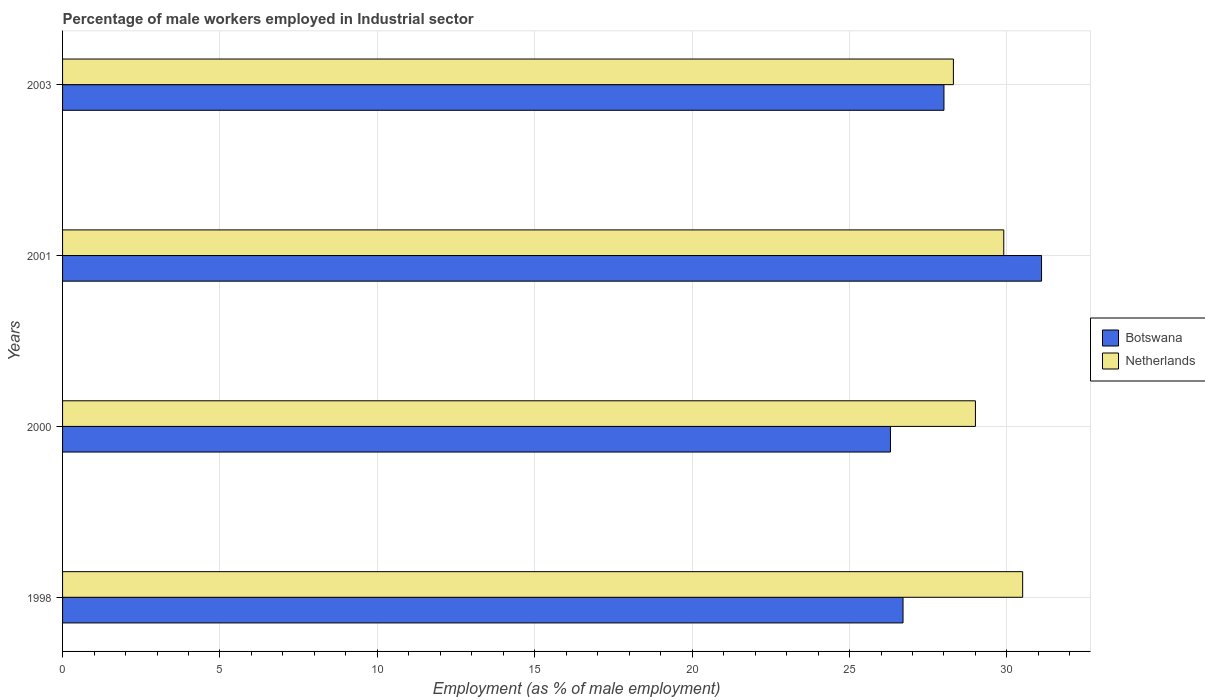Are the number of bars per tick equal to the number of legend labels?
Your response must be concise. Yes. Are the number of bars on each tick of the Y-axis equal?
Make the answer very short. Yes. What is the label of the 2nd group of bars from the top?
Ensure brevity in your answer.  2001. In how many cases, is the number of bars for a given year not equal to the number of legend labels?
Make the answer very short. 0. What is the percentage of male workers employed in Industrial sector in Netherlands in 2001?
Provide a short and direct response. 29.9. Across all years, what is the maximum percentage of male workers employed in Industrial sector in Netherlands?
Provide a succinct answer. 30.5. Across all years, what is the minimum percentage of male workers employed in Industrial sector in Netherlands?
Make the answer very short. 28.3. In which year was the percentage of male workers employed in Industrial sector in Netherlands minimum?
Your answer should be compact. 2003. What is the total percentage of male workers employed in Industrial sector in Botswana in the graph?
Offer a terse response. 112.1. What is the difference between the percentage of male workers employed in Industrial sector in Botswana in 1998 and that in 2003?
Your answer should be compact. -1.3. What is the difference between the percentage of male workers employed in Industrial sector in Botswana in 2001 and the percentage of male workers employed in Industrial sector in Netherlands in 2003?
Make the answer very short. 2.8. What is the average percentage of male workers employed in Industrial sector in Botswana per year?
Give a very brief answer. 28.03. In the year 2001, what is the difference between the percentage of male workers employed in Industrial sector in Botswana and percentage of male workers employed in Industrial sector in Netherlands?
Offer a terse response. 1.2. What is the ratio of the percentage of male workers employed in Industrial sector in Netherlands in 2000 to that in 2001?
Provide a succinct answer. 0.97. Is the percentage of male workers employed in Industrial sector in Netherlands in 1998 less than that in 2003?
Provide a succinct answer. No. Is the difference between the percentage of male workers employed in Industrial sector in Botswana in 1998 and 2000 greater than the difference between the percentage of male workers employed in Industrial sector in Netherlands in 1998 and 2000?
Your answer should be very brief. No. What is the difference between the highest and the second highest percentage of male workers employed in Industrial sector in Botswana?
Make the answer very short. 3.1. What is the difference between the highest and the lowest percentage of male workers employed in Industrial sector in Netherlands?
Offer a very short reply. 2.2. In how many years, is the percentage of male workers employed in Industrial sector in Botswana greater than the average percentage of male workers employed in Industrial sector in Botswana taken over all years?
Offer a terse response. 1. Is the sum of the percentage of male workers employed in Industrial sector in Netherlands in 2000 and 2001 greater than the maximum percentage of male workers employed in Industrial sector in Botswana across all years?
Your answer should be very brief. Yes. How many bars are there?
Make the answer very short. 8. Are the values on the major ticks of X-axis written in scientific E-notation?
Ensure brevity in your answer.  No. How many legend labels are there?
Your answer should be compact. 2. How are the legend labels stacked?
Make the answer very short. Vertical. What is the title of the graph?
Your answer should be very brief. Percentage of male workers employed in Industrial sector. What is the label or title of the X-axis?
Provide a short and direct response. Employment (as % of male employment). What is the label or title of the Y-axis?
Give a very brief answer. Years. What is the Employment (as % of male employment) of Botswana in 1998?
Provide a succinct answer. 26.7. What is the Employment (as % of male employment) of Netherlands in 1998?
Offer a very short reply. 30.5. What is the Employment (as % of male employment) in Botswana in 2000?
Keep it short and to the point. 26.3. What is the Employment (as % of male employment) of Netherlands in 2000?
Ensure brevity in your answer.  29. What is the Employment (as % of male employment) in Botswana in 2001?
Your answer should be very brief. 31.1. What is the Employment (as % of male employment) in Netherlands in 2001?
Provide a short and direct response. 29.9. What is the Employment (as % of male employment) of Netherlands in 2003?
Provide a succinct answer. 28.3. Across all years, what is the maximum Employment (as % of male employment) of Botswana?
Provide a short and direct response. 31.1. Across all years, what is the maximum Employment (as % of male employment) of Netherlands?
Your response must be concise. 30.5. Across all years, what is the minimum Employment (as % of male employment) in Botswana?
Keep it short and to the point. 26.3. Across all years, what is the minimum Employment (as % of male employment) in Netherlands?
Offer a very short reply. 28.3. What is the total Employment (as % of male employment) in Botswana in the graph?
Provide a short and direct response. 112.1. What is the total Employment (as % of male employment) of Netherlands in the graph?
Give a very brief answer. 117.7. What is the difference between the Employment (as % of male employment) of Netherlands in 1998 and that in 2000?
Give a very brief answer. 1.5. What is the difference between the Employment (as % of male employment) in Netherlands in 1998 and that in 2001?
Keep it short and to the point. 0.6. What is the difference between the Employment (as % of male employment) in Botswana in 2000 and that in 2001?
Make the answer very short. -4.8. What is the difference between the Employment (as % of male employment) in Netherlands in 2000 and that in 2001?
Your answer should be compact. -0.9. What is the difference between the Employment (as % of male employment) in Netherlands in 2001 and that in 2003?
Give a very brief answer. 1.6. What is the difference between the Employment (as % of male employment) of Botswana in 1998 and the Employment (as % of male employment) of Netherlands in 2001?
Give a very brief answer. -3.2. What is the difference between the Employment (as % of male employment) in Botswana in 1998 and the Employment (as % of male employment) in Netherlands in 2003?
Make the answer very short. -1.6. What is the difference between the Employment (as % of male employment) of Botswana in 2000 and the Employment (as % of male employment) of Netherlands in 2003?
Give a very brief answer. -2. What is the difference between the Employment (as % of male employment) in Botswana in 2001 and the Employment (as % of male employment) in Netherlands in 2003?
Your response must be concise. 2.8. What is the average Employment (as % of male employment) of Botswana per year?
Ensure brevity in your answer.  28.02. What is the average Employment (as % of male employment) of Netherlands per year?
Provide a succinct answer. 29.43. In the year 2003, what is the difference between the Employment (as % of male employment) of Botswana and Employment (as % of male employment) of Netherlands?
Offer a very short reply. -0.3. What is the ratio of the Employment (as % of male employment) in Botswana in 1998 to that in 2000?
Offer a terse response. 1.02. What is the ratio of the Employment (as % of male employment) of Netherlands in 1998 to that in 2000?
Your answer should be very brief. 1.05. What is the ratio of the Employment (as % of male employment) of Botswana in 1998 to that in 2001?
Provide a short and direct response. 0.86. What is the ratio of the Employment (as % of male employment) of Netherlands in 1998 to that in 2001?
Your response must be concise. 1.02. What is the ratio of the Employment (as % of male employment) of Botswana in 1998 to that in 2003?
Ensure brevity in your answer.  0.95. What is the ratio of the Employment (as % of male employment) of Netherlands in 1998 to that in 2003?
Make the answer very short. 1.08. What is the ratio of the Employment (as % of male employment) of Botswana in 2000 to that in 2001?
Provide a succinct answer. 0.85. What is the ratio of the Employment (as % of male employment) of Netherlands in 2000 to that in 2001?
Offer a very short reply. 0.97. What is the ratio of the Employment (as % of male employment) in Botswana in 2000 to that in 2003?
Provide a short and direct response. 0.94. What is the ratio of the Employment (as % of male employment) in Netherlands in 2000 to that in 2003?
Provide a succinct answer. 1.02. What is the ratio of the Employment (as % of male employment) in Botswana in 2001 to that in 2003?
Make the answer very short. 1.11. What is the ratio of the Employment (as % of male employment) of Netherlands in 2001 to that in 2003?
Ensure brevity in your answer.  1.06. What is the difference between the highest and the second highest Employment (as % of male employment) in Botswana?
Your answer should be very brief. 3.1. What is the difference between the highest and the second highest Employment (as % of male employment) of Netherlands?
Keep it short and to the point. 0.6. 